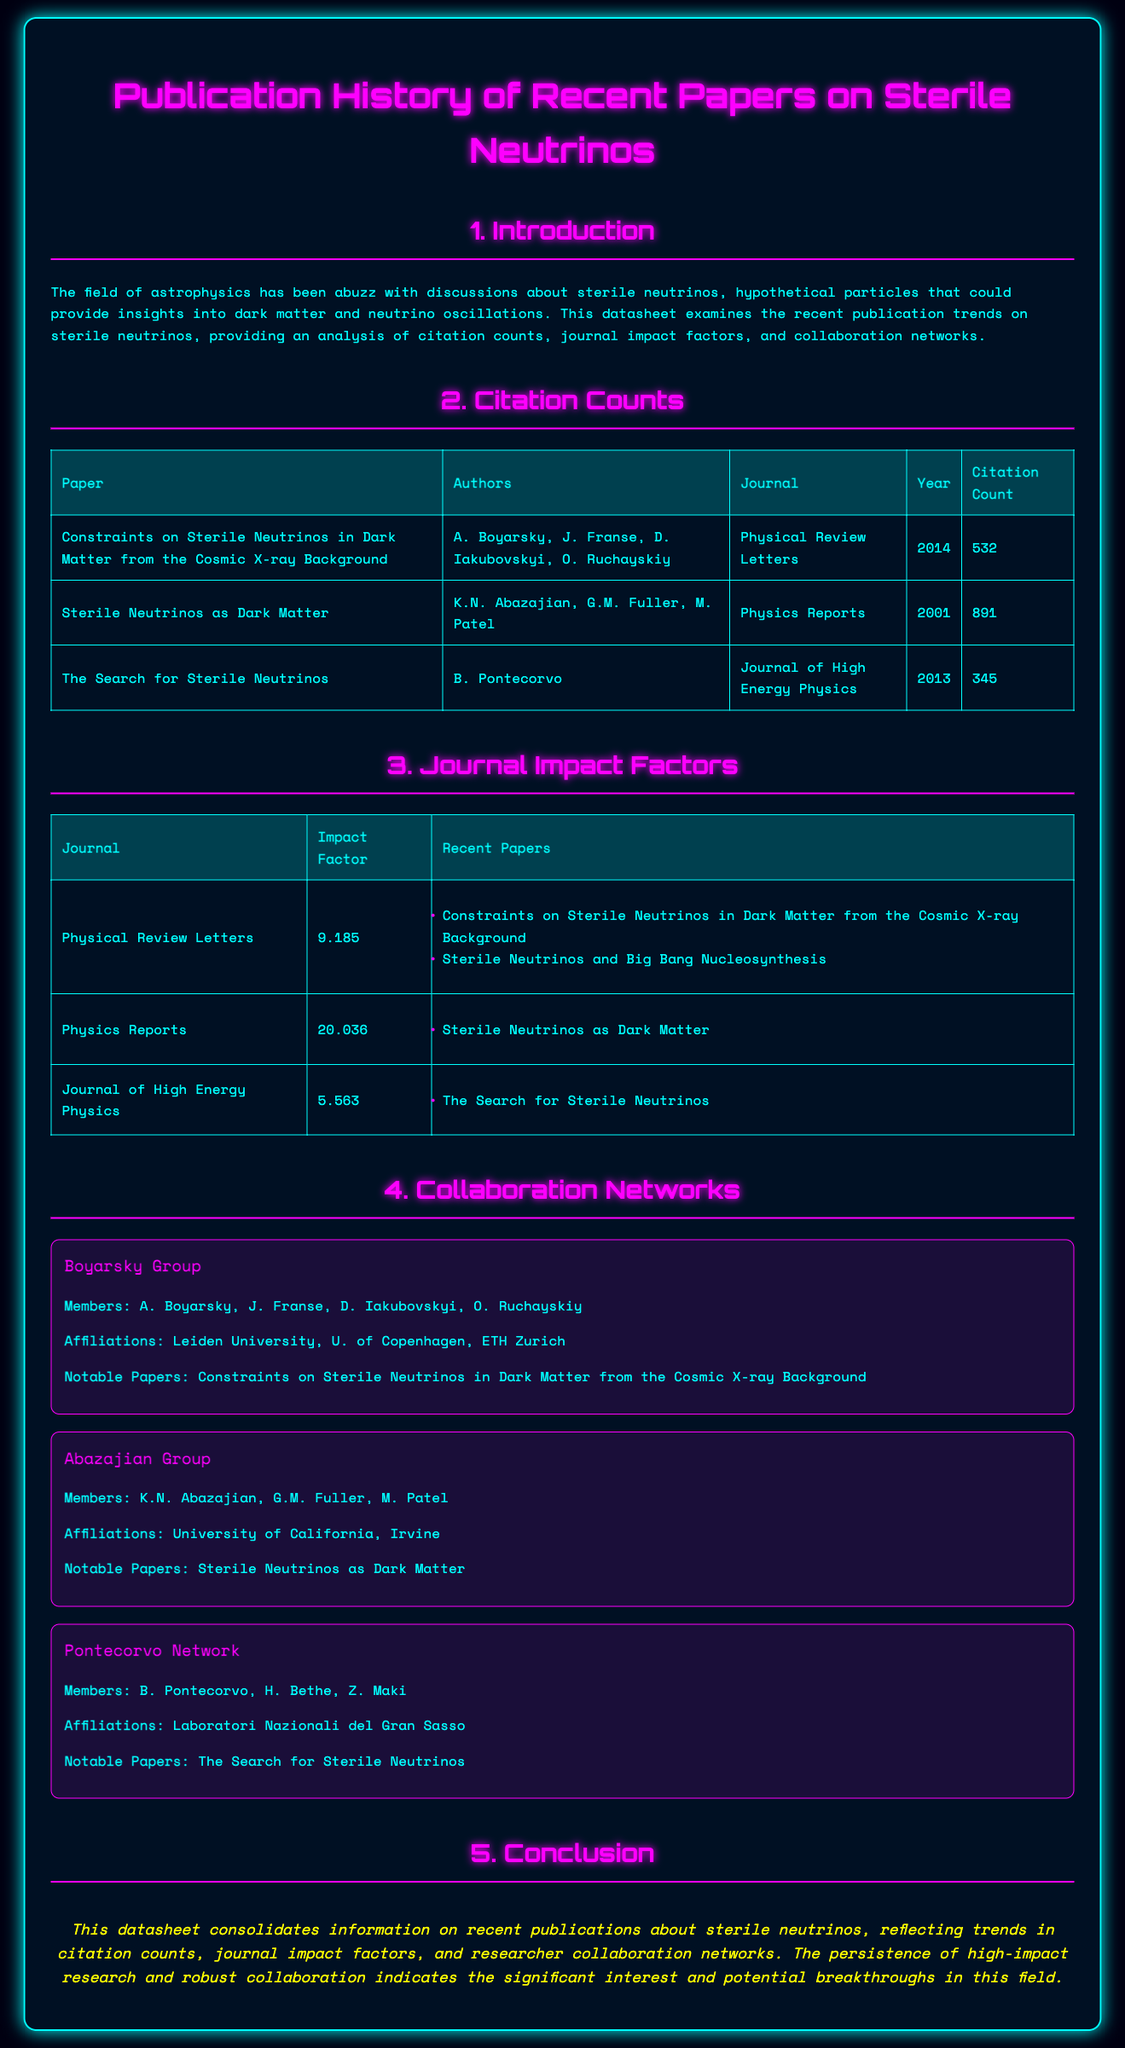What is the citation count for the paper "Sterile Neutrinos as Dark Matter"? The citation count for this paper is listed in the table under Citation Counts, showing 891.
Answer: 891 Who are the authors of the paper "Constraints on Sterile Neutrinos in Dark Matter from the Cosmic X-ray Background"? The authors are detailed in the Citation Counts section, which includes A. Boyarsky, J. Franse, D. Iakubovskyi, O. Ruchayskiy.
Answer: A. Boyarsky, J. Franse, D. Iakubovskyi, O. Ruchayskiy What is the impact factor of the journal "Physics Reports"? The impact factor is provided in the Journal Impact Factors table, which states it is 20.036.
Answer: 20.036 Which collaboration network includes B. Pontecorvo? The document lists "Pontecorvo Network" as the collaboration network that includes him, along with other members.
Answer: Pontecorvo Network How many notable papers are listed under "Physical Review Letters"? The Notable Papers section for this journal contains two papers, as shown in the Journal Impact Factors table.
Answer: 2 What year was "The Search for Sterile Neutrinos" published? The publication year is listed in the Citation Counts table, indicating it was published in 2013.
Answer: 2013 Which university is associated with the Abazajian Group? The affiliations of the group are mentioned in the Collaboration Networks section, specifying University of California, Irvine.
Answer: University of California, Irvine What conclusion does the datasheet reach regarding sterile neutrinos research? The conclusion, found in the conclusion section, suggests a significant interest and potential breakthroughs in the field.
Answer: Significant interest and potential breakthroughs 